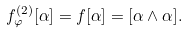Convert formula to latex. <formula><loc_0><loc_0><loc_500><loc_500>f ^ { ( 2 ) } _ { \varphi } [ \alpha ] = f [ \alpha ] = [ \alpha \wedge \alpha ] .</formula> 